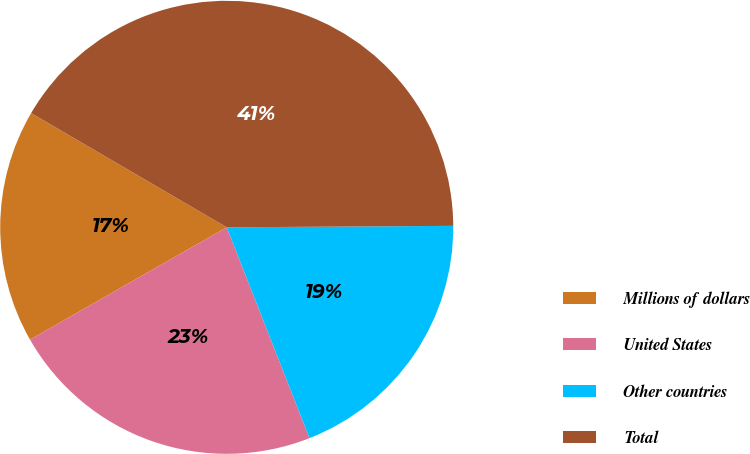<chart> <loc_0><loc_0><loc_500><loc_500><pie_chart><fcel>Millions of dollars<fcel>United States<fcel>Other countries<fcel>Total<nl><fcel>16.67%<fcel>22.7%<fcel>19.15%<fcel>41.49%<nl></chart> 